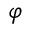Convert formula to latex. <formula><loc_0><loc_0><loc_500><loc_500>\varphi</formula> 